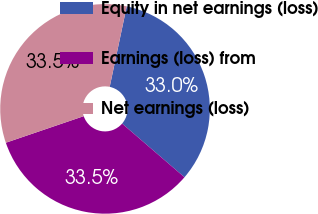<chart> <loc_0><loc_0><loc_500><loc_500><pie_chart><fcel>Equity in net earnings (loss)<fcel>Earnings (loss) from<fcel>Net earnings (loss)<nl><fcel>32.99%<fcel>33.46%<fcel>33.55%<nl></chart> 